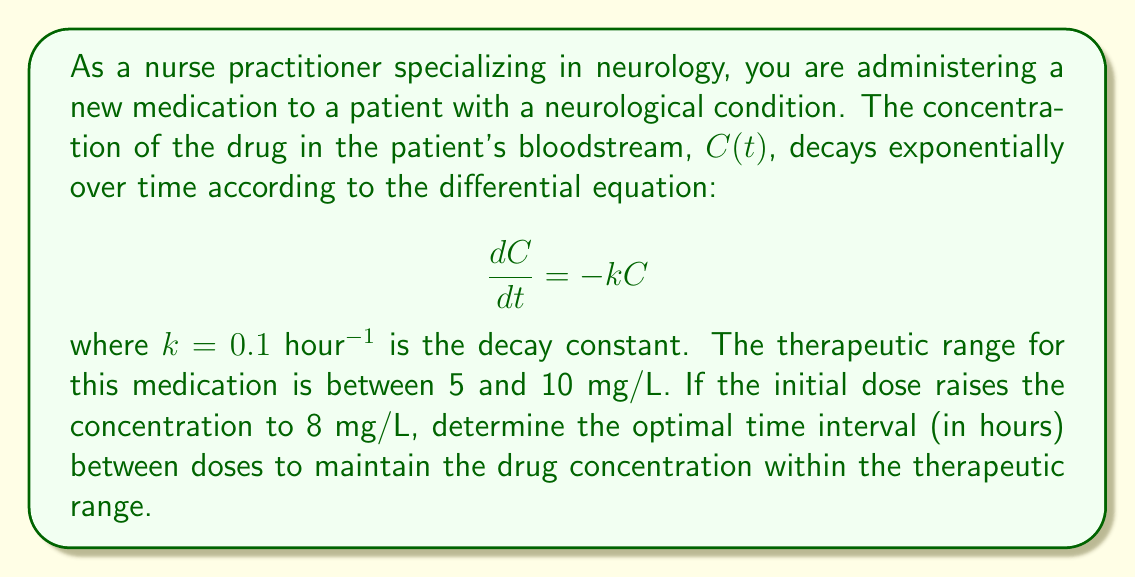Can you answer this question? To solve this problem, we'll follow these steps:

1) The general solution to the differential equation $\frac{dC}{dt} = -kC$ is:

   $$C(t) = C_0e^{-kt}$$

   where $C_0$ is the initial concentration.

2) We're given that $C_0 = 8$ mg/L and $k = 0.1$ hour$^{-1}$. Substituting these values:

   $$C(t) = 8e^{-0.1t}$$

3) To find the optimal time interval, we need to determine when the concentration reaches the lower therapeutic limit of 5 mg/L:

   $$5 = 8e^{-0.1t}$$

4) Solving for $t$:

   $$\frac{5}{8} = e^{-0.1t}$$
   $$\ln(\frac{5}{8}) = -0.1t$$
   $$t = -\frac{\ln(\frac{5}{8})}{0.1} \approx 4.73$$

5) Therefore, the optimal time to administer the next dose is approximately 4.73 hours after the previous dose.

6) To verify, we can check the concentration at this time:

   $$C(4.73) = 8e^{-0.1(4.73)} \approx 5.00$$

   This confirms that the concentration reaches the lower limit of the therapeutic range at this time.
Answer: 4.73 hours 